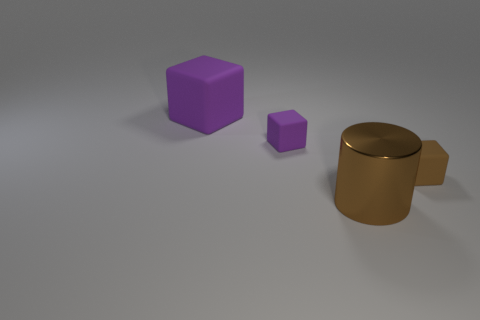What is the large object in front of the small brown rubber thing made of?
Your response must be concise. Metal. How many shiny things are either cubes or cyan cylinders?
Keep it short and to the point. 0. Is there another metallic thing of the same size as the metal object?
Provide a short and direct response. No. Is the number of small objects behind the large matte thing greater than the number of purple things?
Ensure brevity in your answer.  No. How many small objects are purple rubber objects or metallic cylinders?
Your answer should be very brief. 1. What number of small things are the same shape as the large shiny object?
Keep it short and to the point. 0. What material is the big object in front of the tiny brown cube that is right of the large purple block?
Your answer should be compact. Metal. What size is the purple object that is left of the small purple rubber thing?
Ensure brevity in your answer.  Large. What number of gray things are either small rubber objects or objects?
Provide a succinct answer. 0. Is there anything else that is made of the same material as the large purple object?
Offer a terse response. Yes. 